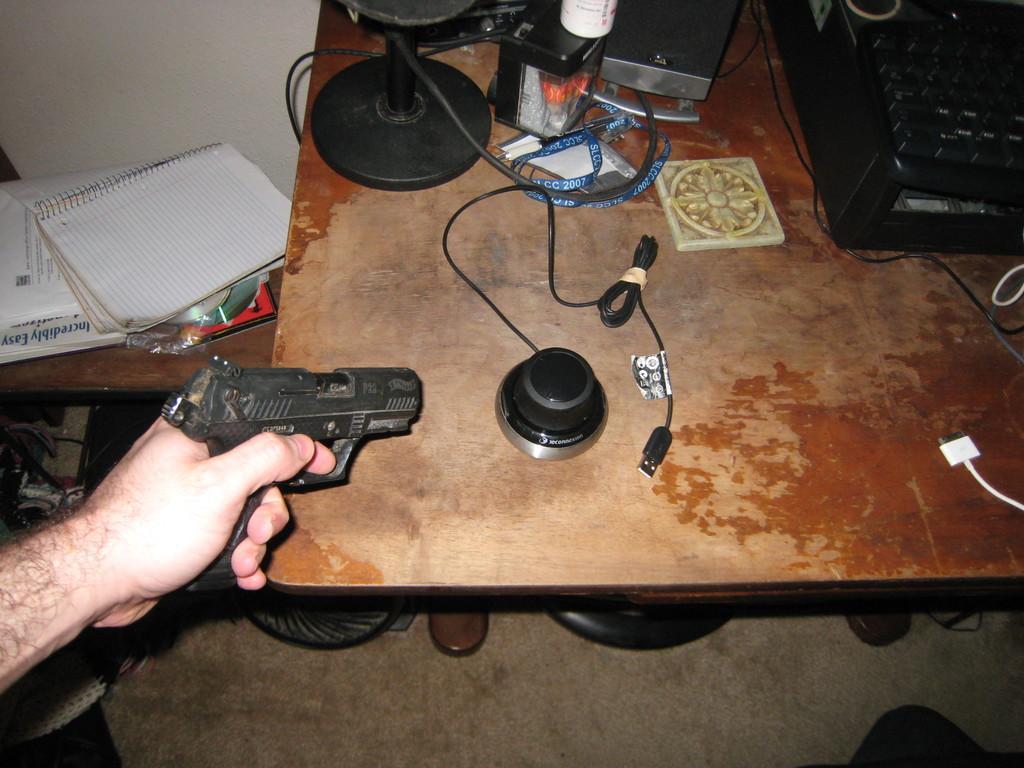In one or two sentences, can you explain what this image depicts? In this picture there is a brown color table, on the top there is a black color typewriter, id card and small speaker. On the left corner there is a person hand holding a black color gun. Behind there is a white book and a wall. 